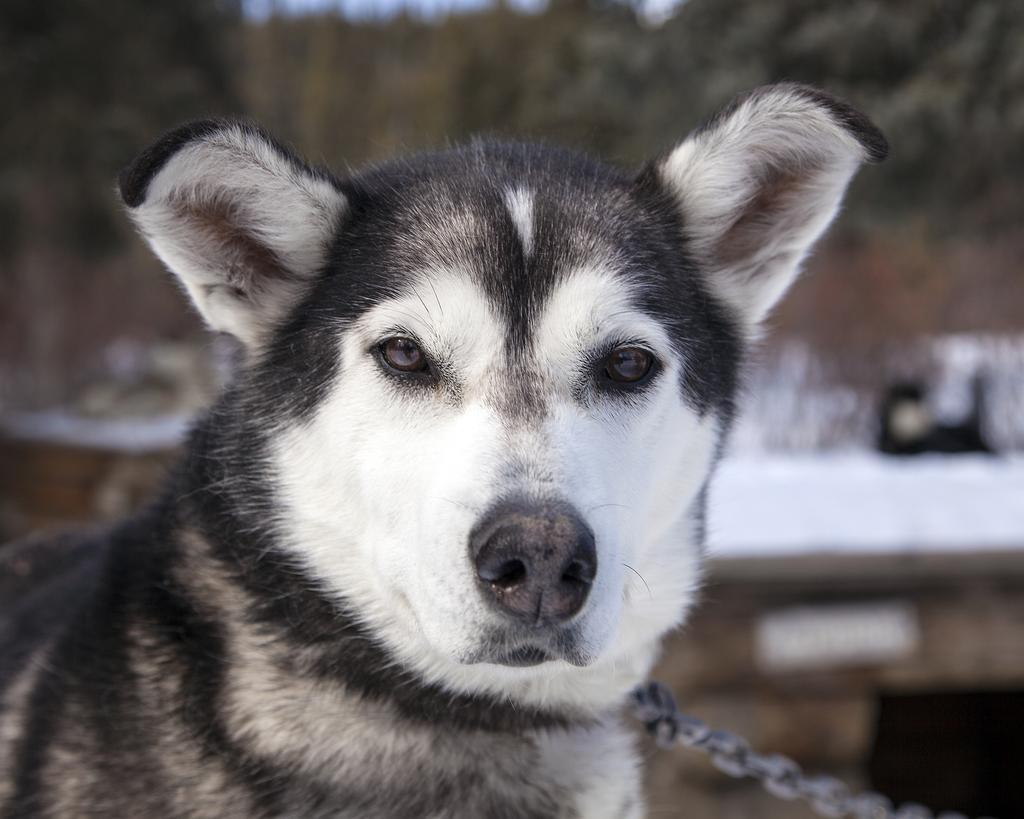What type of animal is present in the image? There is a dog in the image. What is attached to the dog's collar in the image? There is an iron chain at the bottom of the image. Can you describe the background of the image? The background of the image appears blurry. What type of marble is being used to feed the cow in the image? There is no cow or marble present in the image; it features a dog with an iron chain. How many wristbands can be seen on the dog's wrist in the image? There is no wristband or wrist visible in the image, as it features a dog with an iron chain. 